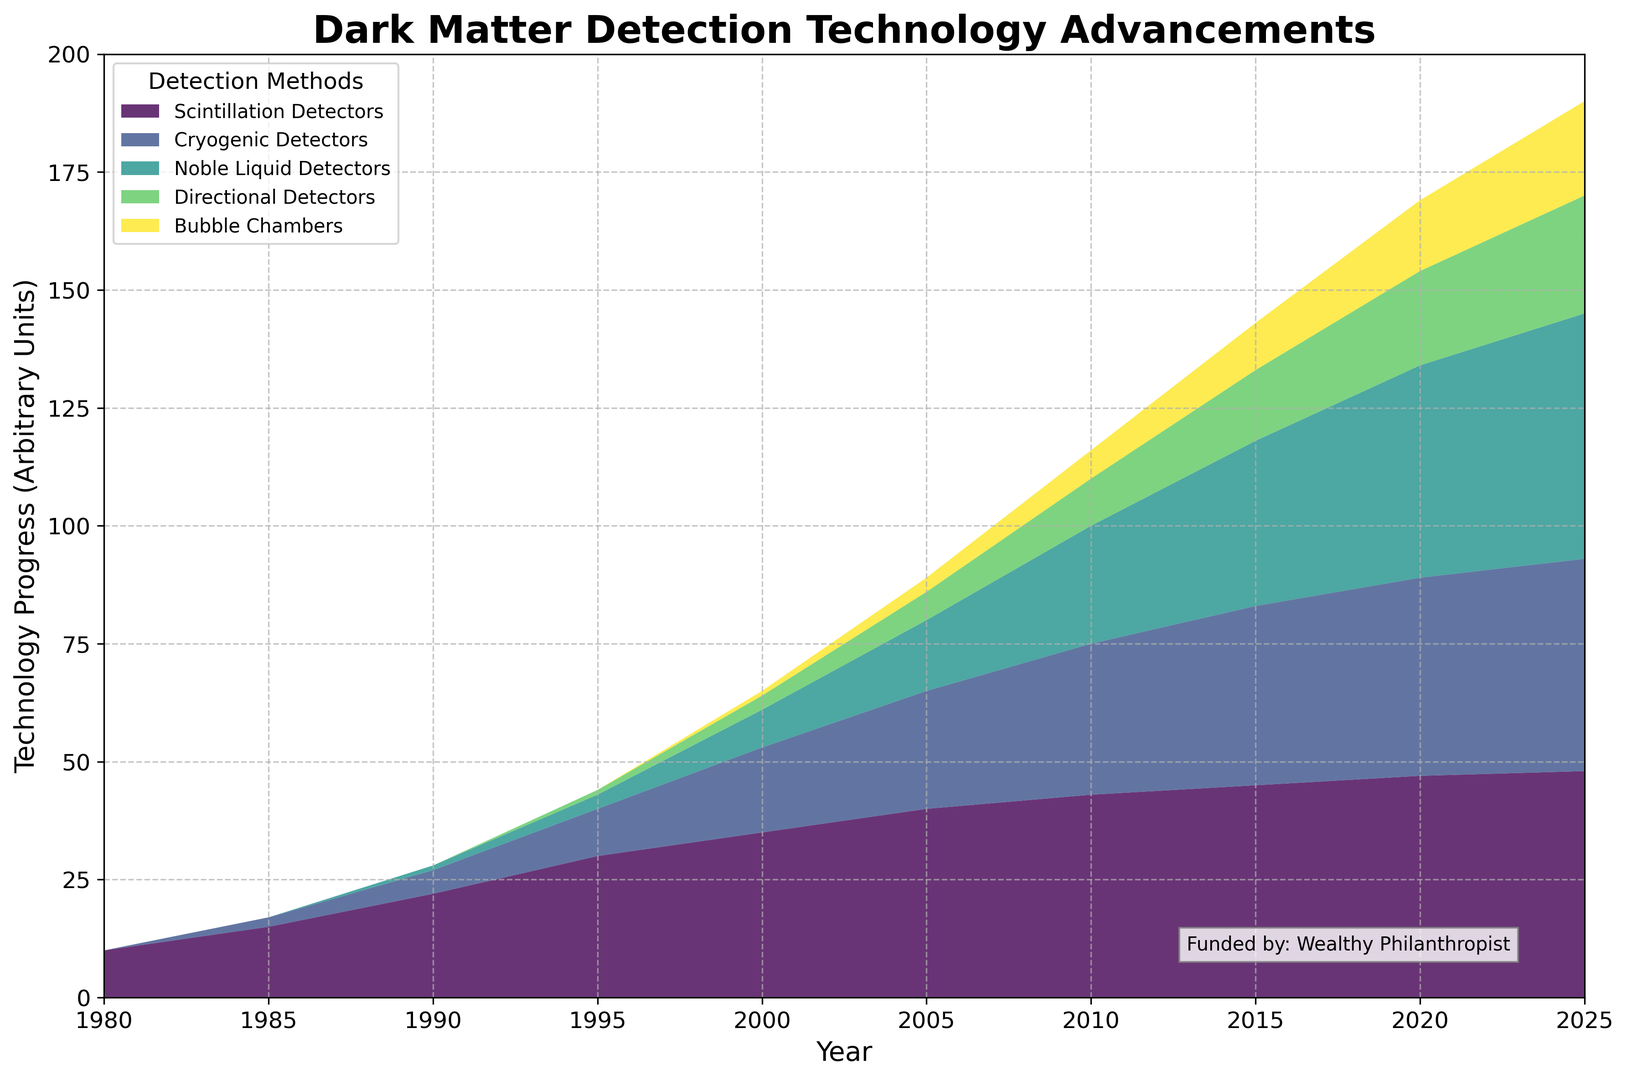Which detection method had the most significant increase in usage between 1980 and 2025? The increase in usage can be determined by comparing the values in 1980 and 2025. Scintillation Detectors grew from 10 to 48, Cryogenic Detectors from 0 to 45, Noble Liquid Detectors from 0 to 52, Directional Detectors from 0 to 25, and Bubble Chambers from 0 to 20. Noble Liquid Detectors had the most significant increase, growing by 52 units.
Answer: Noble Liquid Detectors How does the progression of Bubble Chambers compare to Cryogenic Detectors by 2020? Bubble Chambers reached 15 units in 2020, while Cryogenic Detectors reached 42 units. To compare, we subtract these values, showing that Cryogenic Detectors have 27 more units than Bubble Chambers in 2020.
Answer: Cryogenic Detectors progressed more What is the visual trend of Scintillation Detectors over the years? The area representing Scintillation Detectors starts at the bottom and grows steadily, indicating a gradual but consistent increase over the years from 1980 to 2025.
Answer: Gradual increase By 2010, which detection method out of Scintillation Detectors and Noble Liquid Detectors had made greater advancements? In 2010, Scintillation Detectors are at 43 units, while Noble Liquid Detectors are at 25 units. Scintillation Detectors had greater advancements by that time.
Answer: Scintillation Detectors In what year did Directional Detectors first show progress, and how much did it increase by 2025? Directional Detectors first showed progress in 1995 with 1 unit. By 2025, it had reached 25 units. Thus, it increased by 24 units.
Answer: 1995, increased by 24 units Which detection method shows the highest usage in the year 2005, and how much is it? In 2005, the Scintillation Detectors show the highest usage at 40 units.
Answer: Scintillation Detectors, 40 units What is the overall trend of detection technologies from 1980 to 2025? The overall trend of all detection technologies shows a steady and consistent increase in their advancements from 1980 to 2025, with new technologies appearing and expanding over time.
Answer: Increasing trend If we sum the advancements across all technologies in the year 2000, what is the total? Summing the values: Scintillation Detectors (35), Cryogenic Detectors (18), Noble Liquid Detectors (8), Directional Detectors (3), and Bubble Chambers (1), we get a total of 35 + 18 + 8 + 3 + 1 = 65 units.
Answer: 65 units How do the advancements of Scintillation Detectors and Noble Liquid Detectors compare in 2025? In 2025, advancements for Scintillation Detectors are 48 units, and for Noble Liquid Detectors, it's 52 units. Noble Liquid Detectors have 4 more units than Scintillation Detectors.
Answer: Noble Liquid Detectors have 4 more units 